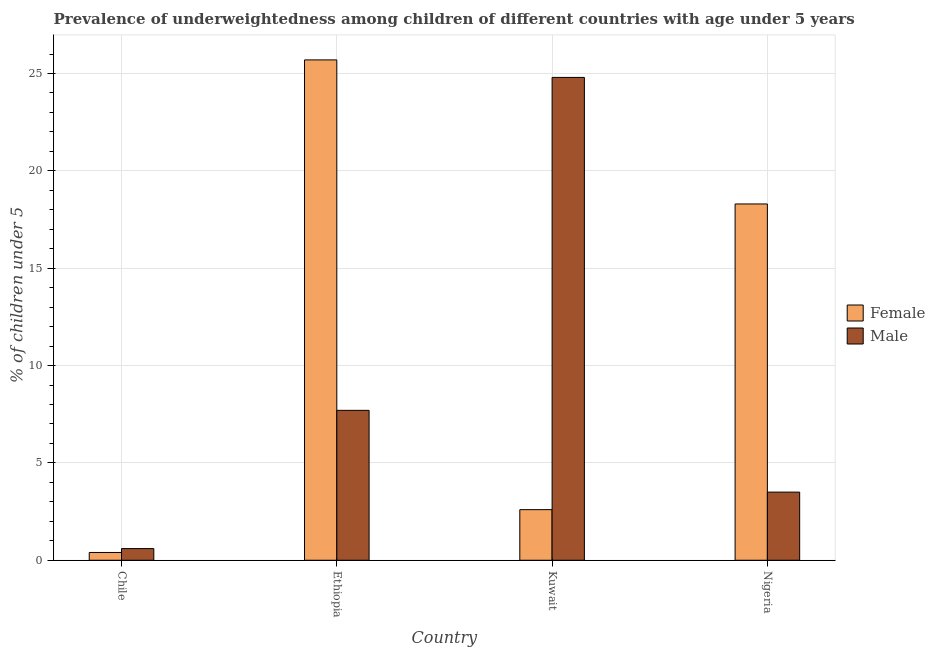How many different coloured bars are there?
Offer a very short reply. 2. Are the number of bars per tick equal to the number of legend labels?
Make the answer very short. Yes. Are the number of bars on each tick of the X-axis equal?
Your response must be concise. Yes. How many bars are there on the 1st tick from the right?
Provide a succinct answer. 2. What is the label of the 3rd group of bars from the left?
Offer a terse response. Kuwait. What is the percentage of underweighted female children in Kuwait?
Provide a short and direct response. 2.6. Across all countries, what is the maximum percentage of underweighted male children?
Keep it short and to the point. 24.8. Across all countries, what is the minimum percentage of underweighted male children?
Provide a short and direct response. 0.6. In which country was the percentage of underweighted female children maximum?
Make the answer very short. Ethiopia. In which country was the percentage of underweighted female children minimum?
Give a very brief answer. Chile. What is the total percentage of underweighted male children in the graph?
Provide a short and direct response. 36.6. What is the difference between the percentage of underweighted male children in Ethiopia and that in Kuwait?
Ensure brevity in your answer.  -17.1. What is the difference between the percentage of underweighted female children in Chile and the percentage of underweighted male children in Kuwait?
Give a very brief answer. -24.4. What is the average percentage of underweighted male children per country?
Provide a succinct answer. 9.15. What is the difference between the percentage of underweighted female children and percentage of underweighted male children in Chile?
Provide a short and direct response. -0.2. What is the ratio of the percentage of underweighted female children in Ethiopia to that in Nigeria?
Make the answer very short. 1.4. Is the difference between the percentage of underweighted female children in Chile and Nigeria greater than the difference between the percentage of underweighted male children in Chile and Nigeria?
Ensure brevity in your answer.  No. What is the difference between the highest and the second highest percentage of underweighted male children?
Keep it short and to the point. 17.1. What is the difference between the highest and the lowest percentage of underweighted male children?
Provide a short and direct response. 24.2. Is the sum of the percentage of underweighted female children in Chile and Nigeria greater than the maximum percentage of underweighted male children across all countries?
Provide a succinct answer. No. What does the 1st bar from the left in Ethiopia represents?
Your response must be concise. Female. How many bars are there?
Offer a terse response. 8. How many countries are there in the graph?
Make the answer very short. 4. What is the difference between two consecutive major ticks on the Y-axis?
Provide a succinct answer. 5. Are the values on the major ticks of Y-axis written in scientific E-notation?
Your answer should be compact. No. Where does the legend appear in the graph?
Make the answer very short. Center right. How many legend labels are there?
Your answer should be compact. 2. What is the title of the graph?
Your response must be concise. Prevalence of underweightedness among children of different countries with age under 5 years. What is the label or title of the X-axis?
Provide a short and direct response. Country. What is the label or title of the Y-axis?
Give a very brief answer.  % of children under 5. What is the  % of children under 5 in Female in Chile?
Make the answer very short. 0.4. What is the  % of children under 5 of Male in Chile?
Keep it short and to the point. 0.6. What is the  % of children under 5 of Female in Ethiopia?
Your answer should be very brief. 25.7. What is the  % of children under 5 of Male in Ethiopia?
Your response must be concise. 7.7. What is the  % of children under 5 of Female in Kuwait?
Ensure brevity in your answer.  2.6. What is the  % of children under 5 of Male in Kuwait?
Provide a succinct answer. 24.8. What is the  % of children under 5 of Female in Nigeria?
Offer a terse response. 18.3. What is the  % of children under 5 in Male in Nigeria?
Provide a succinct answer. 3.5. Across all countries, what is the maximum  % of children under 5 in Female?
Give a very brief answer. 25.7. Across all countries, what is the maximum  % of children under 5 of Male?
Your answer should be compact. 24.8. Across all countries, what is the minimum  % of children under 5 in Female?
Your answer should be compact. 0.4. Across all countries, what is the minimum  % of children under 5 in Male?
Offer a terse response. 0.6. What is the total  % of children under 5 of Male in the graph?
Your answer should be very brief. 36.6. What is the difference between the  % of children under 5 in Female in Chile and that in Ethiopia?
Ensure brevity in your answer.  -25.3. What is the difference between the  % of children under 5 of Male in Chile and that in Ethiopia?
Provide a succinct answer. -7.1. What is the difference between the  % of children under 5 of Male in Chile and that in Kuwait?
Provide a succinct answer. -24.2. What is the difference between the  % of children under 5 in Female in Chile and that in Nigeria?
Provide a succinct answer. -17.9. What is the difference between the  % of children under 5 in Male in Chile and that in Nigeria?
Your answer should be compact. -2.9. What is the difference between the  % of children under 5 of Female in Ethiopia and that in Kuwait?
Offer a very short reply. 23.1. What is the difference between the  % of children under 5 in Male in Ethiopia and that in Kuwait?
Offer a terse response. -17.1. What is the difference between the  % of children under 5 of Female in Ethiopia and that in Nigeria?
Provide a short and direct response. 7.4. What is the difference between the  % of children under 5 of Male in Ethiopia and that in Nigeria?
Ensure brevity in your answer.  4.2. What is the difference between the  % of children under 5 of Female in Kuwait and that in Nigeria?
Give a very brief answer. -15.7. What is the difference between the  % of children under 5 in Male in Kuwait and that in Nigeria?
Make the answer very short. 21.3. What is the difference between the  % of children under 5 in Female in Chile and the  % of children under 5 in Male in Ethiopia?
Your response must be concise. -7.3. What is the difference between the  % of children under 5 of Female in Chile and the  % of children under 5 of Male in Kuwait?
Your response must be concise. -24.4. What is the difference between the  % of children under 5 in Female in Chile and the  % of children under 5 in Male in Nigeria?
Offer a very short reply. -3.1. What is the difference between the  % of children under 5 in Female in Kuwait and the  % of children under 5 in Male in Nigeria?
Provide a succinct answer. -0.9. What is the average  % of children under 5 in Female per country?
Your response must be concise. 11.75. What is the average  % of children under 5 in Male per country?
Offer a terse response. 9.15. What is the difference between the  % of children under 5 of Female and  % of children under 5 of Male in Chile?
Offer a terse response. -0.2. What is the difference between the  % of children under 5 of Female and  % of children under 5 of Male in Ethiopia?
Provide a succinct answer. 18. What is the difference between the  % of children under 5 of Female and  % of children under 5 of Male in Kuwait?
Ensure brevity in your answer.  -22.2. What is the difference between the  % of children under 5 of Female and  % of children under 5 of Male in Nigeria?
Make the answer very short. 14.8. What is the ratio of the  % of children under 5 in Female in Chile to that in Ethiopia?
Offer a very short reply. 0.02. What is the ratio of the  % of children under 5 of Male in Chile to that in Ethiopia?
Give a very brief answer. 0.08. What is the ratio of the  % of children under 5 of Female in Chile to that in Kuwait?
Your response must be concise. 0.15. What is the ratio of the  % of children under 5 of Male in Chile to that in Kuwait?
Ensure brevity in your answer.  0.02. What is the ratio of the  % of children under 5 in Female in Chile to that in Nigeria?
Ensure brevity in your answer.  0.02. What is the ratio of the  % of children under 5 in Male in Chile to that in Nigeria?
Keep it short and to the point. 0.17. What is the ratio of the  % of children under 5 in Female in Ethiopia to that in Kuwait?
Your response must be concise. 9.88. What is the ratio of the  % of children under 5 of Male in Ethiopia to that in Kuwait?
Your answer should be very brief. 0.31. What is the ratio of the  % of children under 5 of Female in Ethiopia to that in Nigeria?
Your answer should be very brief. 1.4. What is the ratio of the  % of children under 5 of Female in Kuwait to that in Nigeria?
Your response must be concise. 0.14. What is the ratio of the  % of children under 5 in Male in Kuwait to that in Nigeria?
Your response must be concise. 7.09. What is the difference between the highest and the second highest  % of children under 5 of Male?
Your answer should be very brief. 17.1. What is the difference between the highest and the lowest  % of children under 5 in Female?
Offer a very short reply. 25.3. What is the difference between the highest and the lowest  % of children under 5 in Male?
Your answer should be very brief. 24.2. 